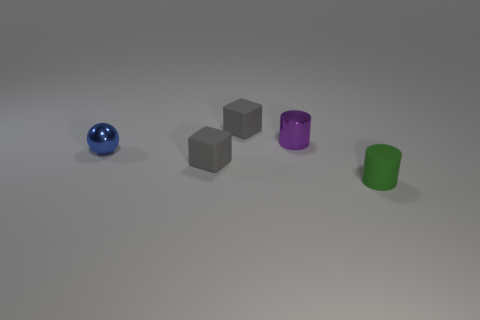Add 2 small cyan metal cylinders. How many objects exist? 7 Subtract all cylinders. How many objects are left? 3 Subtract all yellow shiny objects. Subtract all small things. How many objects are left? 0 Add 5 green objects. How many green objects are left? 6 Add 4 gray metal spheres. How many gray metal spheres exist? 4 Subtract 0 yellow cylinders. How many objects are left? 5 